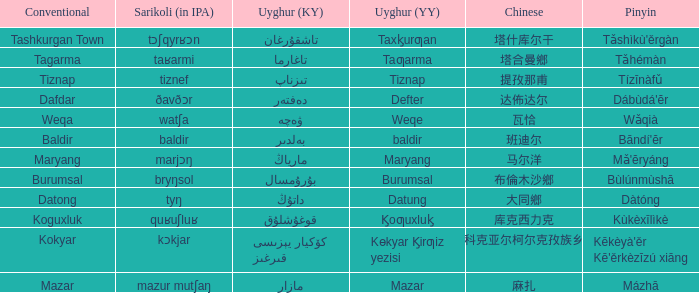Name the pinyin for mazar Mázhā. 